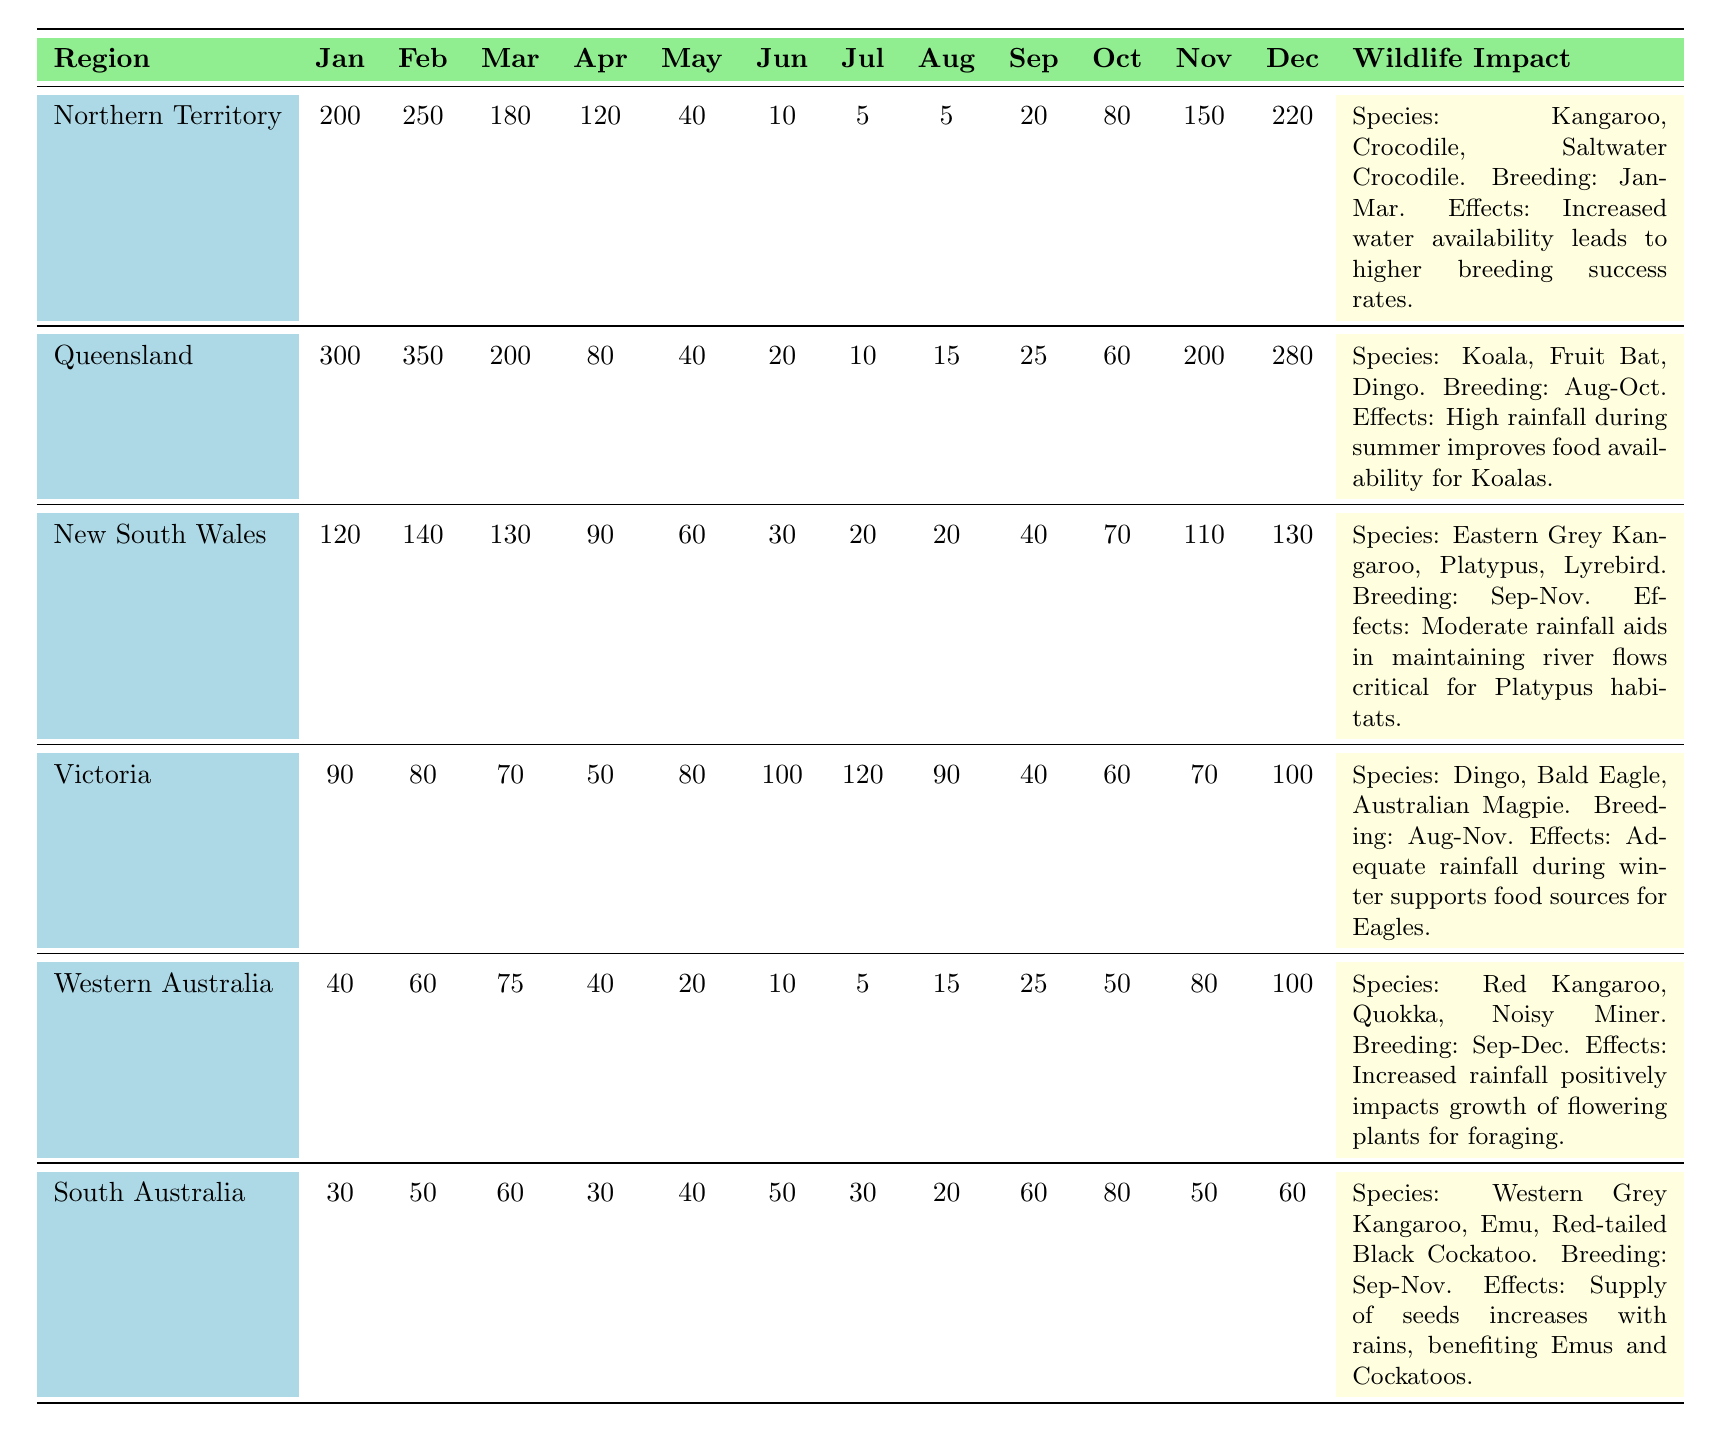What is the total rainfall in Queensland for the months of January and February? The rainfall in Queensland for January is 300mm and for February it is 350mm. Adding these two values together: 300 + 350 = 650mm.
Answer: 650mm Which region has the highest rainfall in December? Looking at the table, Queensland has the highest rainfall in December, which is 280mm.
Answer: Queensland How many species of wildlife are reported for South Australia? The table shows that South Australia has three species listed: Western Grey Kangaroo, Emu, and Red-tailed Black Cockatoo.
Answer: 3 What is the average rainfall in January across all regions? To find the average, first sum the January rainfall: 200 + 300 + 120 + 90 + 40 + 30 = 780mm. There are 6 regions, so the average is 780/6 = 130mm.
Answer: 130mm Does Western Australia have more total rainfall than South Australia throughout the year? Summing all monthly rainfall for Western Australia gives 40 + 60 + 75 + 40 + 20 + 10 + 5 + 15 + 25 + 50 + 80 + 100 = 510mm. For South Australia, it's 30 + 50 + 60 + 30 + 40 + 50 + 30 + 20 + 60 + 80 + 50 + 60 = 510mm, making them equal.
Answer: No In which region do kangaroos have a breeding season that overlaps with the highest rainfall months? For Northern Territory, the breeding season is January - March, which includes the months with the highest rainfall, particularly February at 250mm.
Answer: Northern Territory What month has the lowest average rainfall across all regions? The rainfall amounts must be summed for each month and then averaged: January (780mm), February (840mm), March (675mm), April (410mm), May (310mm), June (220mm), July (180mm), August (140mm), September (250mm), October (350mm), November (430mm), and December (520mm). The lowest average rainfall is in July with 180mm.
Answer: July Which two regions have the same total rainfall during the months of September to December? Calculating total rainfall from September to December gives: Queensland (25 + 60 + 200 + 280 = 565mm) and South Australia (60 + 80 + 50 + 60 = 250mm). The two regions with equal totals are not found as values differ.
Answer: None What impact does increased rainfall during the breeding season have on the koalas in Queensland? The table indicates that high rainfall improves food availability for Koalas, supporting their breeding success.
Answer: Improved food availability Which region has the least amount of rainfall in June? From the data, Western Australia has the least rainfall in June at 10mm.
Answer: Western Australia Calculate the total rainfall for Victoria from June to November. Adding the monthly rainfall from June (100mm) to November (70mm): 100 + 120 + 90 + 40 + 60 = 400mm.
Answer: 400mm 